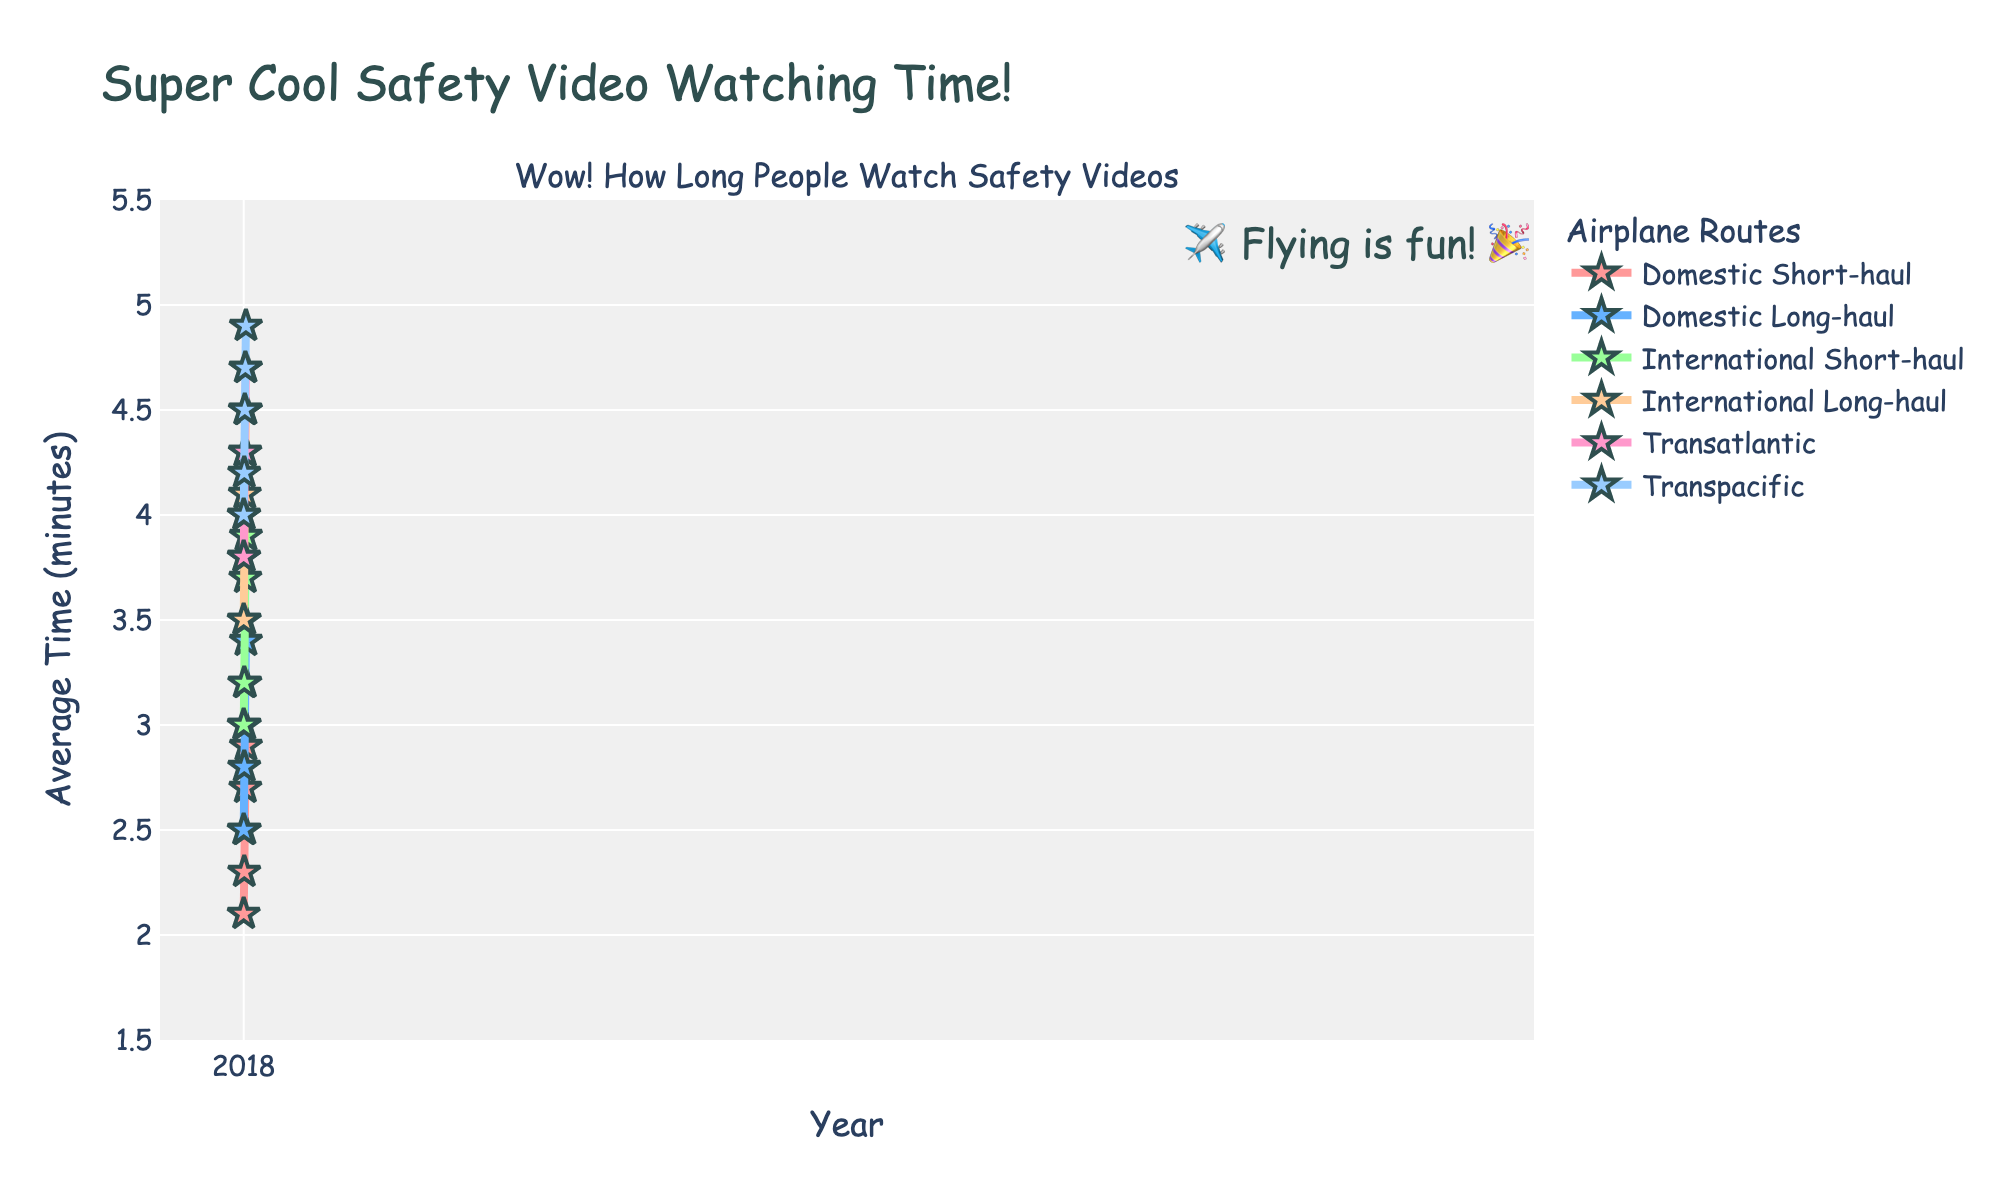How did the average time spent by passengers watching in-flight safety videos on Transatlantic routes change from 2018 to 2022? First, check the value for Transatlantic routes in 2018, which is 3.8 minutes. Then, check for 2022, which is 4.7 minutes. Calculate the difference: 4.7 - 3.8 = 0.9.
Answer: 0.9 minutes Which route had the highest average time spent watching in-flight safety videos in 2022? Look at the last column in the data for the year 2022 and identify the highest value. The highest value is 4.9 for the Transpacific route.
Answer: Transpacific Between Domestic Short-haul and Domestic Long-haul routes, which saw a greater increase in average time spent watching safety videos from 2018 to 2022? For Domestic Short-haul: 2.9 - 2.1 = 0.8. For Domestic Long-haul: 3.4 - 2.5 = 0.9. Compare 0.8 and 0.9, Domestic Long-haul is greater.
Answer: Domestic Long-haul By how much did the average time spent on International Short-haul routes exceed that spent on Domestic Short-haul routes in 2020? Find the average time in 2020 for International Short-haul (3.5) and Domestic Short-haul (2.5). Calculate the difference: 3.5 - 2.5 = 1.0.
Answer: 1.0 minute What is the average increase in time spent watching safety videos per year for Transpacific routes from 2018 to 2022? Calculate the increase from 2018 to 2022: 4.9 - 4.0 = 0.9. There are 4 intervals between 5 years (2018 to 2022). Divide the total increase by 4: 0.9 / 4 = 0.225.
Answer: 0.225 minutes per year Between 2018 and 2022, which route showed the smallest increase in the average time spent watching safety videos? Calculate the increase for each route:
- Domestic Short-haul: 2.9 - 2.1 = 0.8
- Domestic Long-haul: 3.4 - 2.5 = 0.9
- International Short-haul: 3.9 - 3.0 = 0.9
- International Long-haul: 4.5 - 3.5 = 1.0
- Transatlantic: 4.7 - 3.8 = 0.9
- Transpacific: 4.9 - 4.0 = 0.9
The smallest increase is for Domestic Short-haul (0.8).
Answer: Domestic Short-haul In which year did the average time spent on Domestic Long-haul routes first exceed 3 minutes? Inspect the values for Domestic Long-haul in each year. In 2020, the value is 3.0 and in 2021, it is 3.2. So, it first exceeded 3.0 in 2021.
Answer: 2021 What was the average time spent watching safety videos across all routes in 2019? The values for 2019 are:
- Domestic Short-haul: 2.3
- Domestic Long-haul: 2.8
- International Short-haul: 3.2
- International Long-haul: 3.8
- Transatlantic: 4.0
- Transpacific: 4.2
Sum these values: 2.3 + 2.8 + 3.2 + 3.8 + 4.0 + 4.2 = 20.3. Divide by the number of routes (6): 20.3 / 6 = 3.383.
Answer: 3.383 minutes 